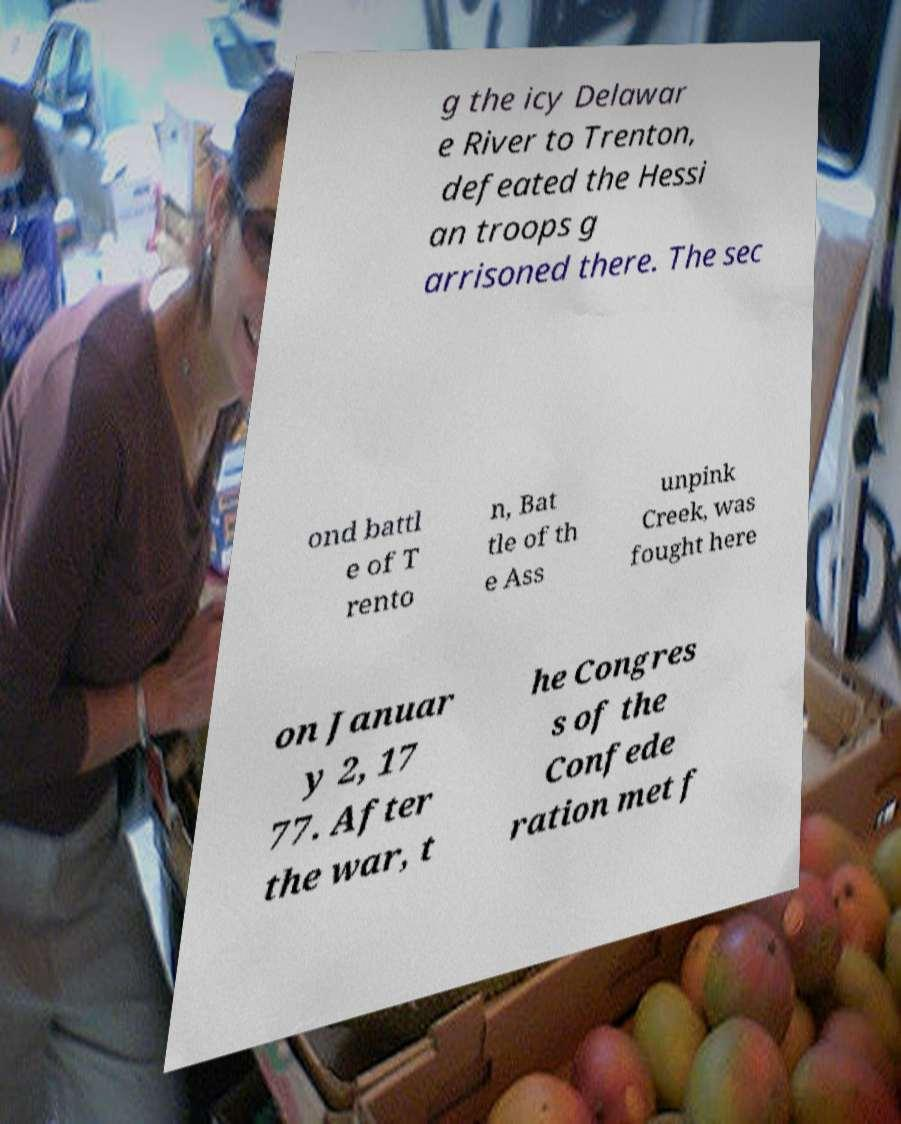I need the written content from this picture converted into text. Can you do that? g the icy Delawar e River to Trenton, defeated the Hessi an troops g arrisoned there. The sec ond battl e of T rento n, Bat tle of th e Ass unpink Creek, was fought here on Januar y 2, 17 77. After the war, t he Congres s of the Confede ration met f 